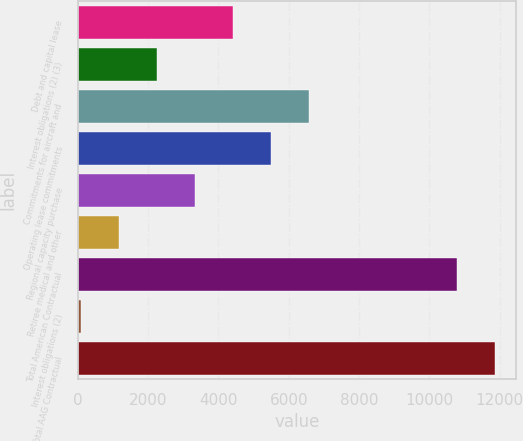Convert chart to OTSL. <chart><loc_0><loc_0><loc_500><loc_500><bar_chart><fcel>Debt and capital lease<fcel>Interest obligations (2) (3)<fcel>Commitments for aircraft and<fcel>Operating lease commitments<fcel>Regional capacity purchase<fcel>Retiree medical and other<fcel>Total American Contractual<fcel>Interest obligations (2)<fcel>Total AAG Contractual<nl><fcel>4418.2<fcel>2257.6<fcel>6578.8<fcel>5498.5<fcel>3337.9<fcel>1177.3<fcel>10794<fcel>97<fcel>11874.3<nl></chart> 